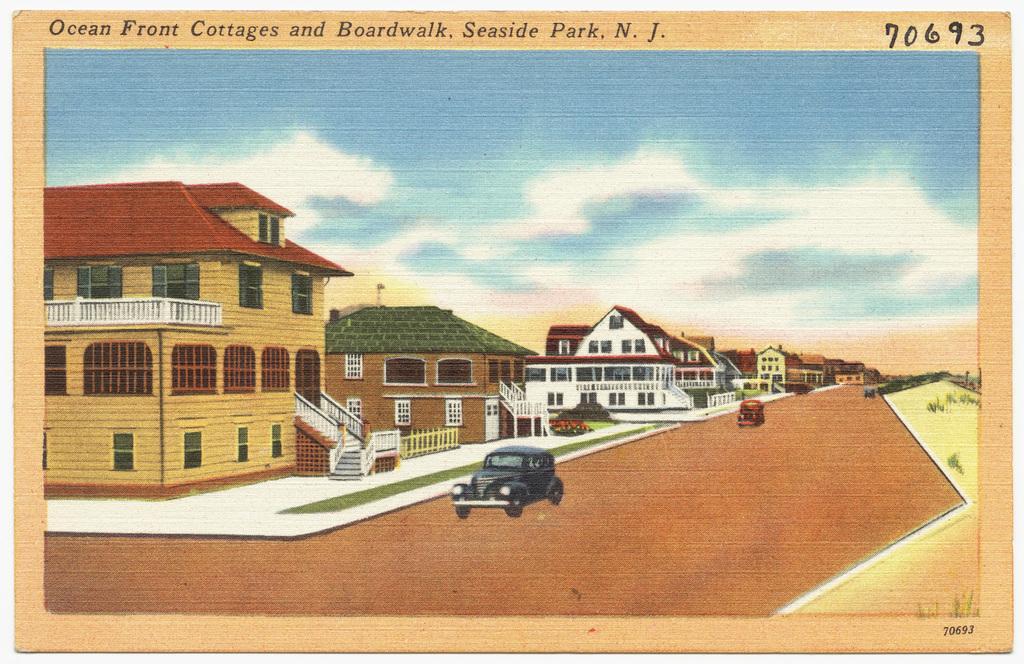Could you give a brief overview of what you see in this image? This is a picture of a painting. In the center of the picture there are buildings, staircase, windows, grass. In the foreground of the picture there are cars, on the road. On the right to the background there are trees. Sky is cloudy. 